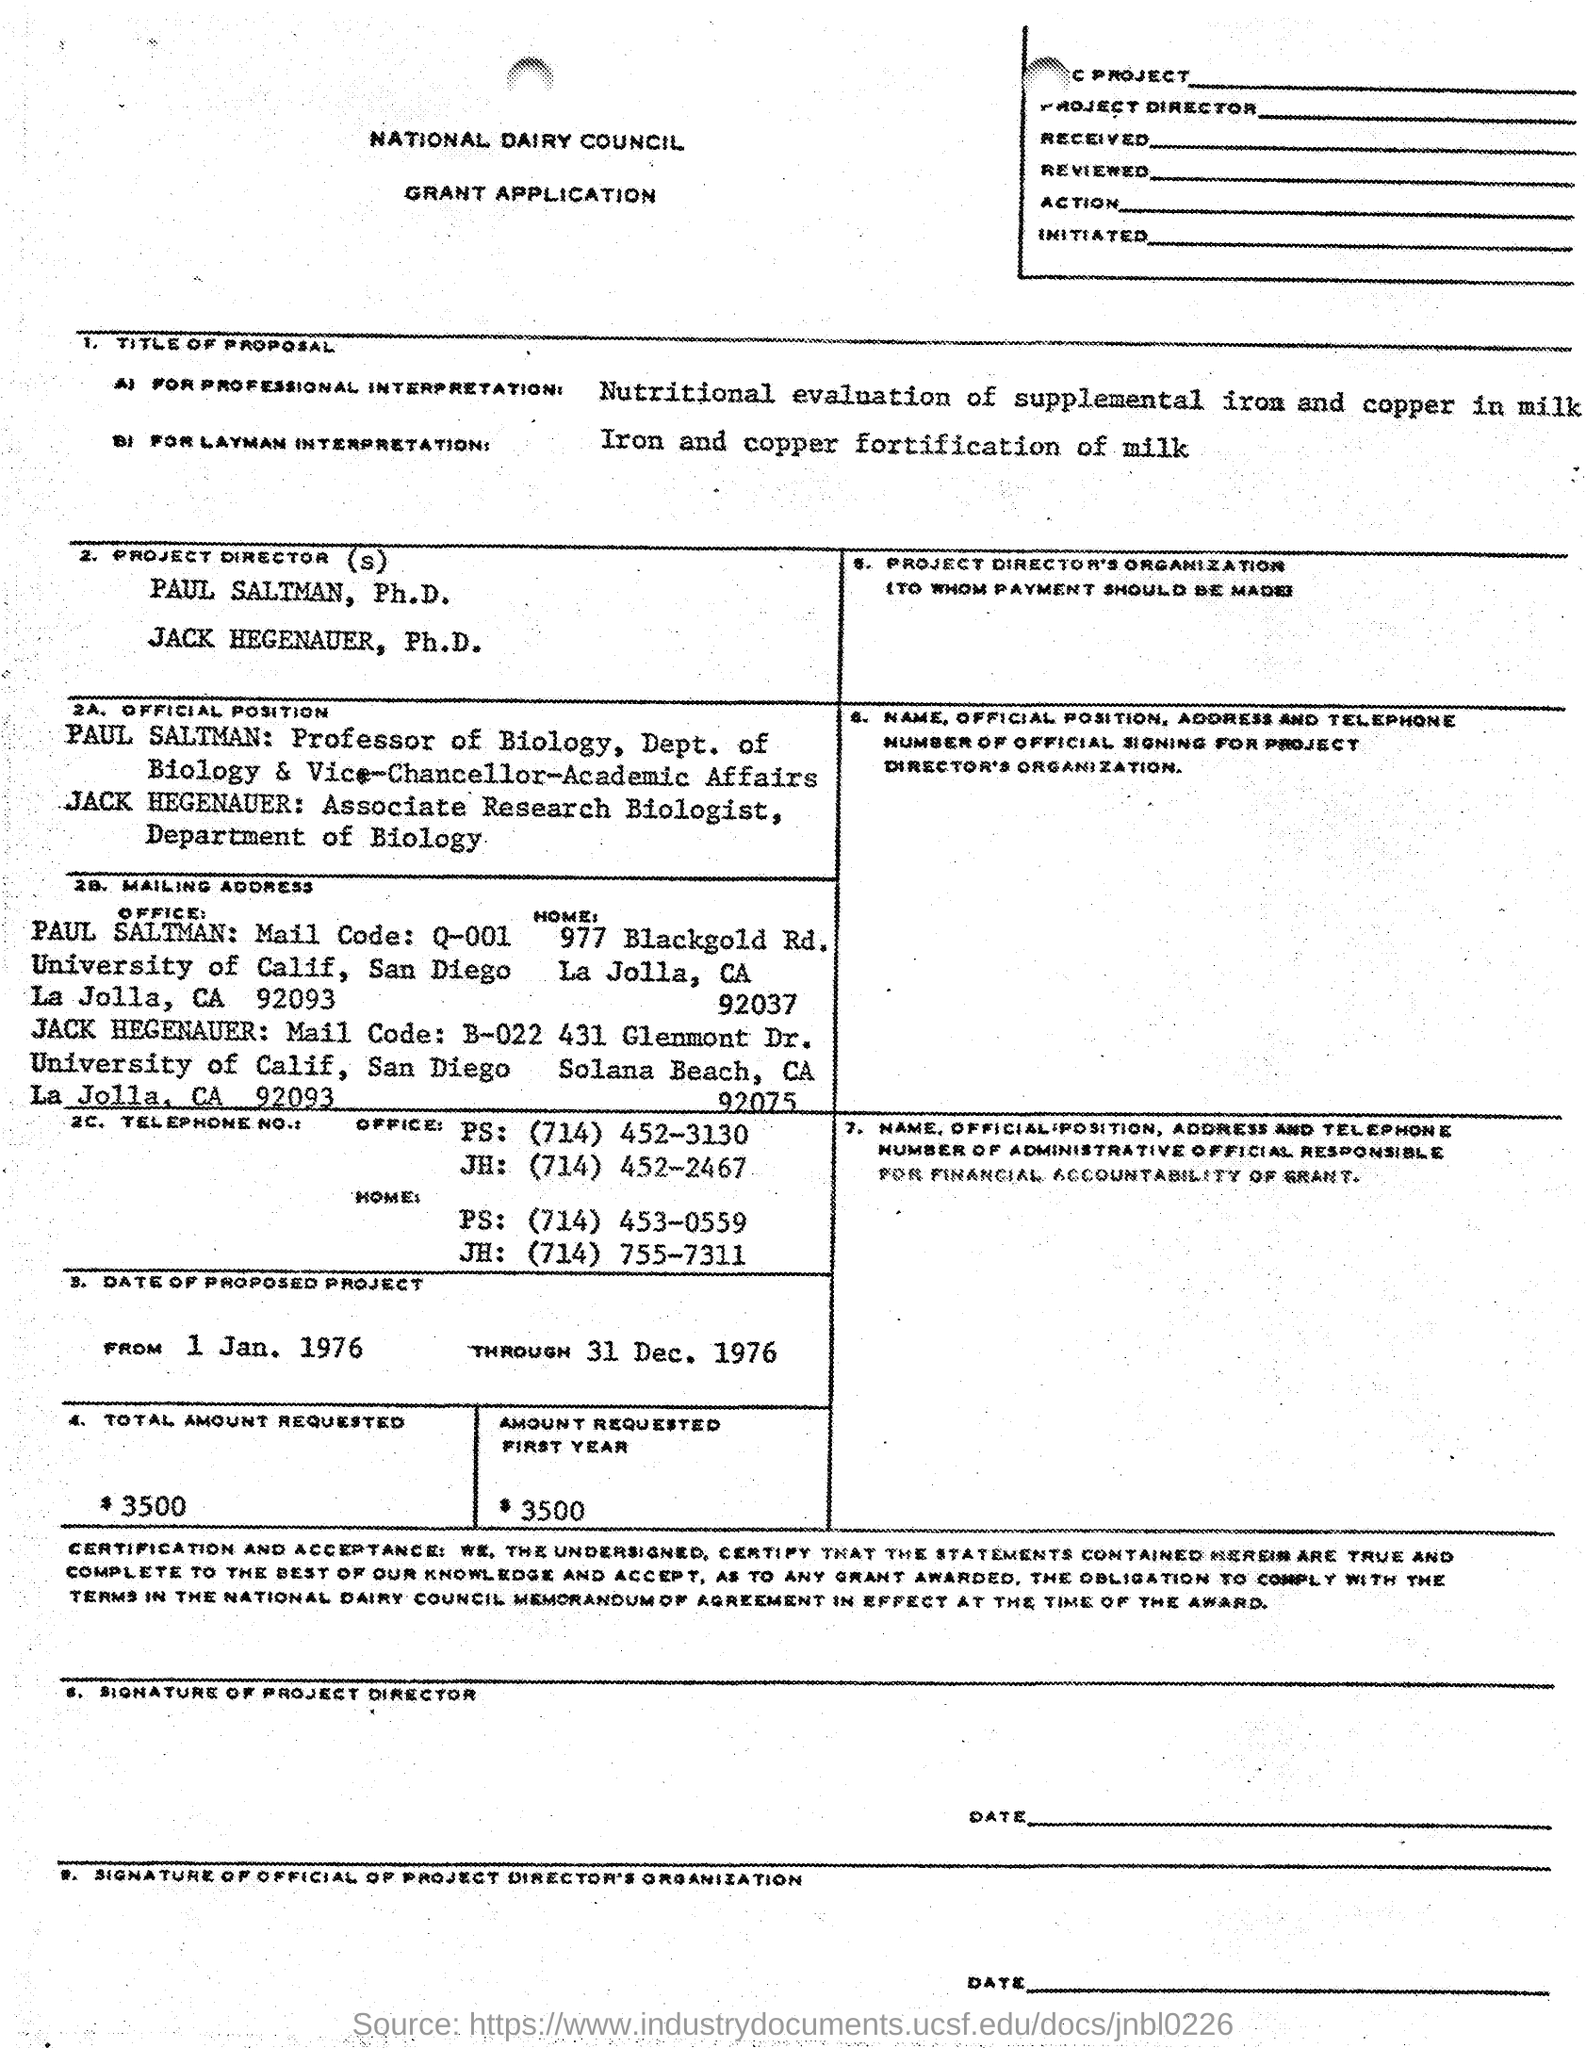Draw attention to some important aspects in this diagram. Paul Saltman is the professor of biology. The Saltman mail code is Q-001. This application belongs to the National Dairy Council. The office telephone number for PS is (714) 452-3130. 